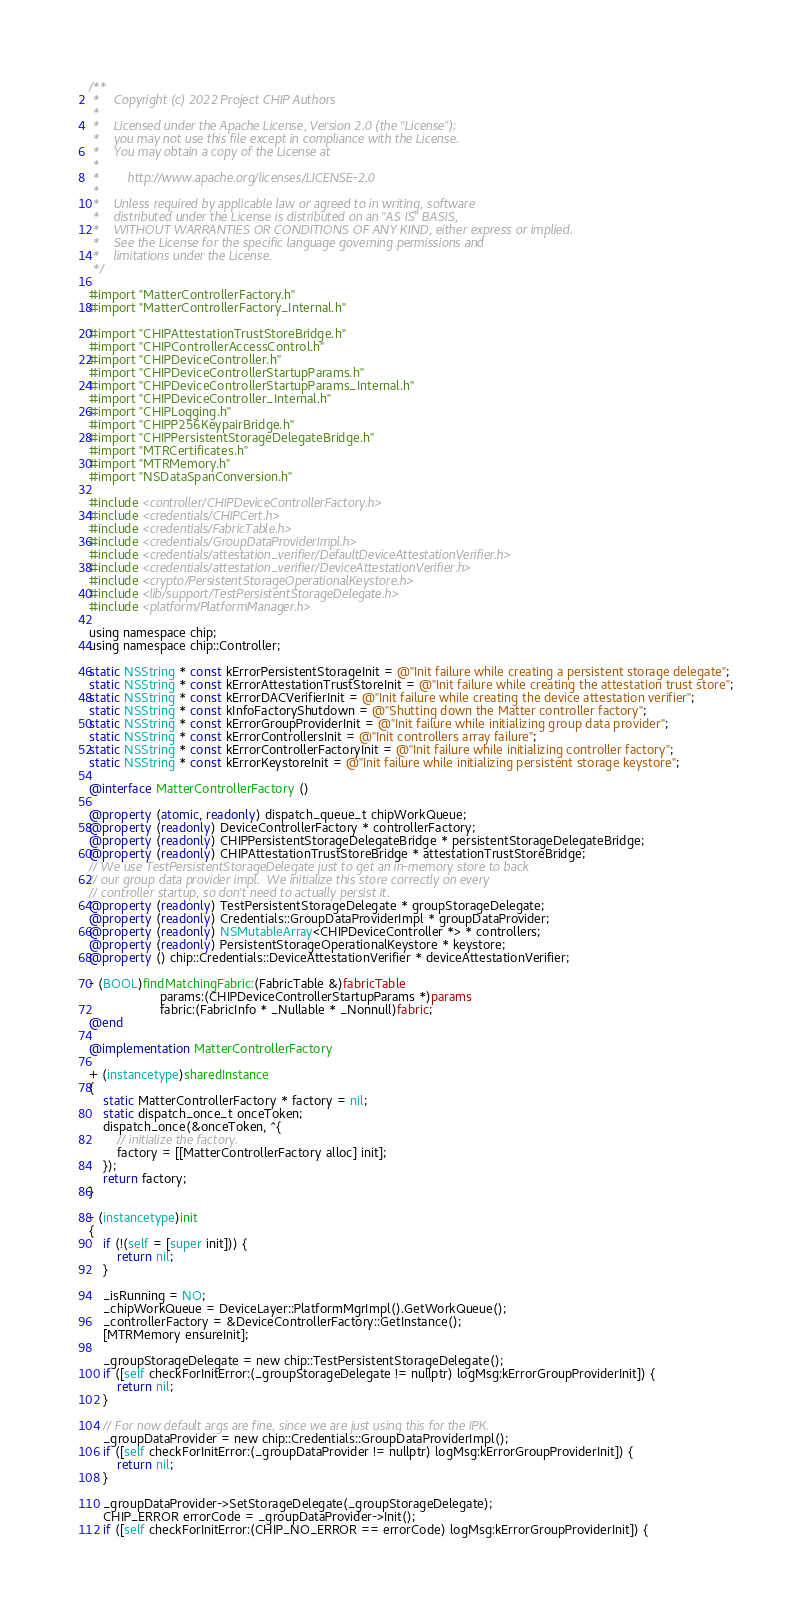Convert code to text. <code><loc_0><loc_0><loc_500><loc_500><_ObjectiveC_>/**
 *    Copyright (c) 2022 Project CHIP Authors
 *
 *    Licensed under the Apache License, Version 2.0 (the "License");
 *    you may not use this file except in compliance with the License.
 *    You may obtain a copy of the License at
 *
 *        http://www.apache.org/licenses/LICENSE-2.0
 *
 *    Unless required by applicable law or agreed to in writing, software
 *    distributed under the License is distributed on an "AS IS" BASIS,
 *    WITHOUT WARRANTIES OR CONDITIONS OF ANY KIND, either express or implied.
 *    See the License for the specific language governing permissions and
 *    limitations under the License.
 */

#import "MatterControllerFactory.h"
#import "MatterControllerFactory_Internal.h"

#import "CHIPAttestationTrustStoreBridge.h"
#import "CHIPControllerAccessControl.h"
#import "CHIPDeviceController.h"
#import "CHIPDeviceControllerStartupParams.h"
#import "CHIPDeviceControllerStartupParams_Internal.h"
#import "CHIPDeviceController_Internal.h"
#import "CHIPLogging.h"
#import "CHIPP256KeypairBridge.h"
#import "CHIPPersistentStorageDelegateBridge.h"
#import "MTRCertificates.h"
#import "MTRMemory.h"
#import "NSDataSpanConversion.h"

#include <controller/CHIPDeviceControllerFactory.h>
#include <credentials/CHIPCert.h>
#include <credentials/FabricTable.h>
#include <credentials/GroupDataProviderImpl.h>
#include <credentials/attestation_verifier/DefaultDeviceAttestationVerifier.h>
#include <credentials/attestation_verifier/DeviceAttestationVerifier.h>
#include <crypto/PersistentStorageOperationalKeystore.h>
#include <lib/support/TestPersistentStorageDelegate.h>
#include <platform/PlatformManager.h>

using namespace chip;
using namespace chip::Controller;

static NSString * const kErrorPersistentStorageInit = @"Init failure while creating a persistent storage delegate";
static NSString * const kErrorAttestationTrustStoreInit = @"Init failure while creating the attestation trust store";
static NSString * const kErrorDACVerifierInit = @"Init failure while creating the device attestation verifier";
static NSString * const kInfoFactoryShutdown = @"Shutting down the Matter controller factory";
static NSString * const kErrorGroupProviderInit = @"Init failure while initializing group data provider";
static NSString * const kErrorControllersInit = @"Init controllers array failure";
static NSString * const kErrorControllerFactoryInit = @"Init failure while initializing controller factory";
static NSString * const kErrorKeystoreInit = @"Init failure while initializing persistent storage keystore";

@interface MatterControllerFactory ()

@property (atomic, readonly) dispatch_queue_t chipWorkQueue;
@property (readonly) DeviceControllerFactory * controllerFactory;
@property (readonly) CHIPPersistentStorageDelegateBridge * persistentStorageDelegateBridge;
@property (readonly) CHIPAttestationTrustStoreBridge * attestationTrustStoreBridge;
// We use TestPersistentStorageDelegate just to get an in-memory store to back
// our group data provider impl.  We initialize this store correctly on every
// controller startup, so don't need to actually persist it.
@property (readonly) TestPersistentStorageDelegate * groupStorageDelegate;
@property (readonly) Credentials::GroupDataProviderImpl * groupDataProvider;
@property (readonly) NSMutableArray<CHIPDeviceController *> * controllers;
@property (readonly) PersistentStorageOperationalKeystore * keystore;
@property () chip::Credentials::DeviceAttestationVerifier * deviceAttestationVerifier;

- (BOOL)findMatchingFabric:(FabricTable &)fabricTable
                    params:(CHIPDeviceControllerStartupParams *)params
                    fabric:(FabricInfo * _Nullable * _Nonnull)fabric;
@end

@implementation MatterControllerFactory

+ (instancetype)sharedInstance
{
    static MatterControllerFactory * factory = nil;
    static dispatch_once_t onceToken;
    dispatch_once(&onceToken, ^{
        // initialize the factory.
        factory = [[MatterControllerFactory alloc] init];
    });
    return factory;
}

- (instancetype)init
{
    if (!(self = [super init])) {
        return nil;
    }

    _isRunning = NO;
    _chipWorkQueue = DeviceLayer::PlatformMgrImpl().GetWorkQueue();
    _controllerFactory = &DeviceControllerFactory::GetInstance();
    [MTRMemory ensureInit];

    _groupStorageDelegate = new chip::TestPersistentStorageDelegate();
    if ([self checkForInitError:(_groupStorageDelegate != nullptr) logMsg:kErrorGroupProviderInit]) {
        return nil;
    }

    // For now default args are fine, since we are just using this for the IPK.
    _groupDataProvider = new chip::Credentials::GroupDataProviderImpl();
    if ([self checkForInitError:(_groupDataProvider != nullptr) logMsg:kErrorGroupProviderInit]) {
        return nil;
    }

    _groupDataProvider->SetStorageDelegate(_groupStorageDelegate);
    CHIP_ERROR errorCode = _groupDataProvider->Init();
    if ([self checkForInitError:(CHIP_NO_ERROR == errorCode) logMsg:kErrorGroupProviderInit]) {</code> 